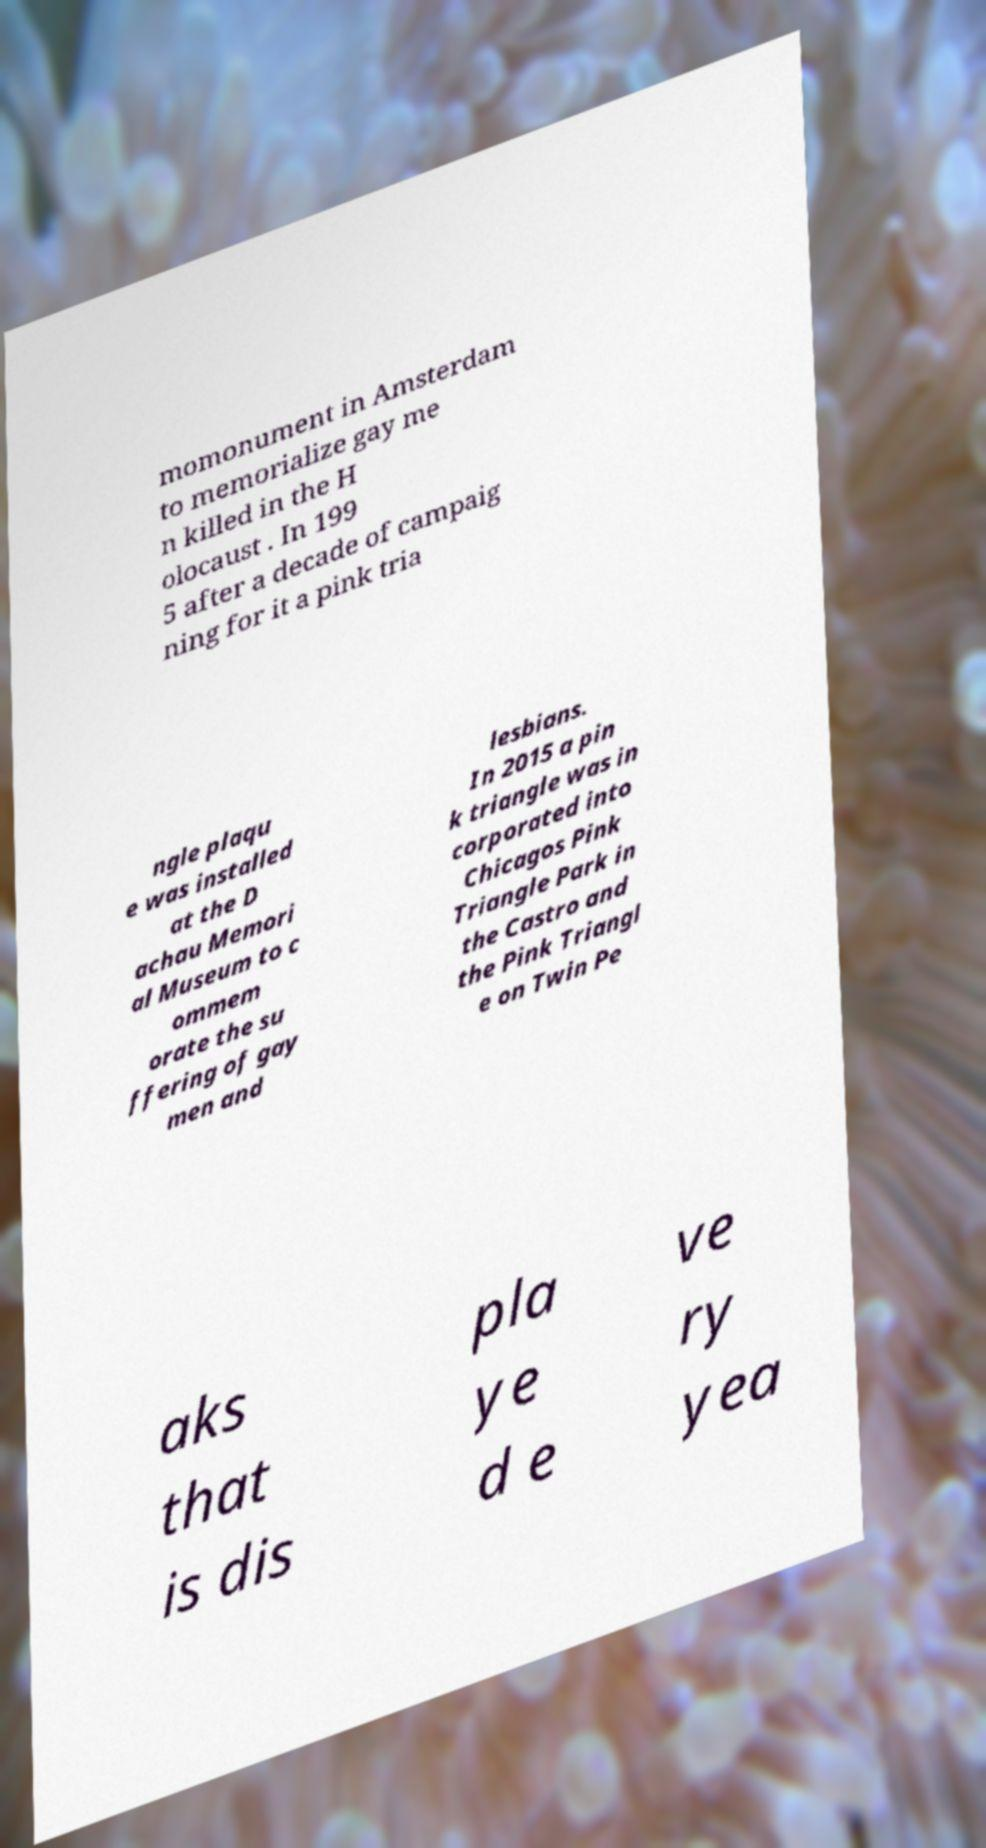There's text embedded in this image that I need extracted. Can you transcribe it verbatim? momonument in Amsterdam to memorialize gay me n killed in the H olocaust . In 199 5 after a decade of campaig ning for it a pink tria ngle plaqu e was installed at the D achau Memori al Museum to c ommem orate the su ffering of gay men and lesbians. In 2015 a pin k triangle was in corporated into Chicagos Pink Triangle Park in the Castro and the Pink Triangl e on Twin Pe aks that is dis pla ye d e ve ry yea 